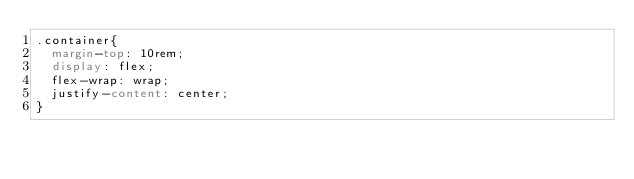<code> <loc_0><loc_0><loc_500><loc_500><_CSS_>.container{
  margin-top: 10rem;
  display: flex;
  flex-wrap: wrap;
  justify-content: center;
}</code> 